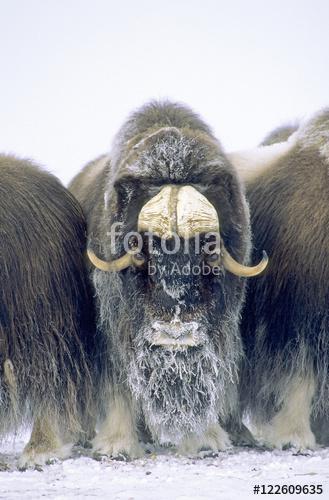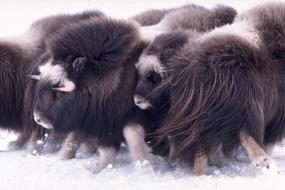The first image is the image on the left, the second image is the image on the right. Evaluate the accuracy of this statement regarding the images: "Buffalo are in a fanned-out circle formation, each animal looking outward, in at least one image.". Is it true? Answer yes or no. No. The first image is the image on the left, the second image is the image on the right. Evaluate the accuracy of this statement regarding the images: "There are buffalo standing in snow.". Is it true? Answer yes or no. Yes. 